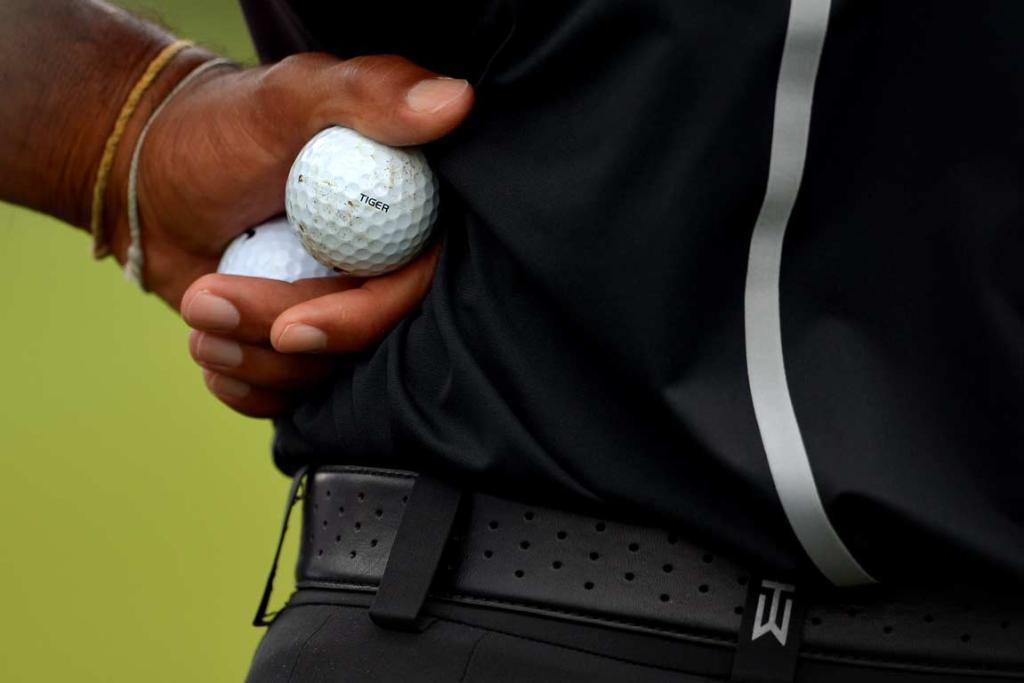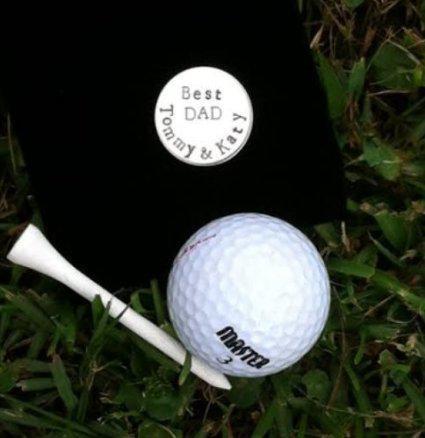The first image is the image on the left, the second image is the image on the right. For the images shown, is this caption "One of the images contains a golf tee touching a golf ball on the ground." true? Answer yes or no. Yes. The first image is the image on the left, the second image is the image on the right. Assess this claim about the two images: "Atleast one image of a person holding 2 balls behind their back". Correct or not? Answer yes or no. Yes. 